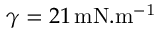Convert formula to latex. <formula><loc_0><loc_0><loc_500><loc_500>\gamma = 2 1 \, m N . m ^ { - 1 }</formula> 